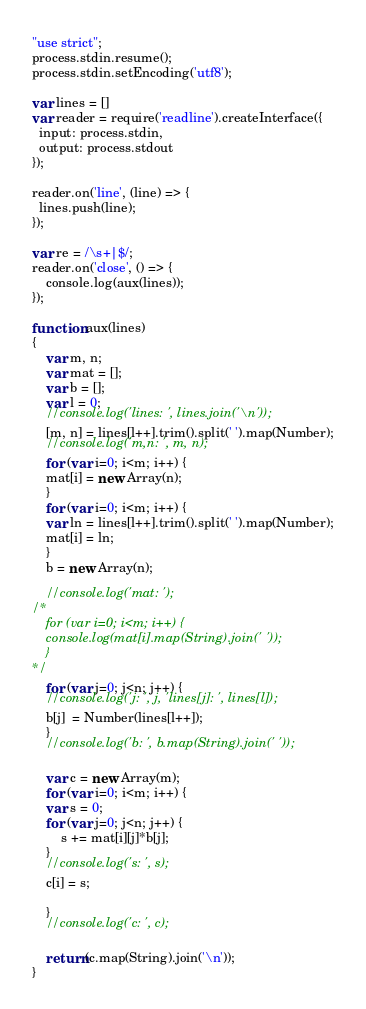Convert code to text. <code><loc_0><loc_0><loc_500><loc_500><_JavaScript_>"use strict";
process.stdin.resume();
process.stdin.setEncoding('utf8');

var lines = []
var reader = require('readline').createInterface({
  input: process.stdin,
  output: process.stdout
});

reader.on('line', (line) => {
  lines.push(line);
});

var re = /\s+|$/;
reader.on('close', () => {
    console.log(aux(lines));
});

function aux(lines)
{
    var m, n;
    var mat = [];
    var b = [];
    var l = 0;
    //console.log('lines: ', lines.join('\n'));
    [m, n] = lines[l++].trim().split(' ').map(Number);
    //console.log('m,n: ', m, n);
    for (var i=0; i<m; i++) {
	mat[i] = new Array(n);
    }
    for (var i=0; i<m; i++) {
	var ln = lines[l++].trim().split(' ').map(Number);
	mat[i] = ln;
    }
    b = new Array(n);

    //console.log('mat: ');
/*
    for (var i=0; i<m; i++) {
	console.log(mat[i].map(String).join(' '));
    }
*/
    for (var j=0; j<n; j++) {
	//console.log('j: ', j, 'lines[j]: ', lines[l]);
	b[j]  = Number(lines[l++]);
    }
    //console.log('b: ', b.map(String).join(' '));

    var c = new Array(m);
    for (var i=0; i<m; i++) {
	var s = 0;
	for (var j=0; j<n; j++) {
	    s += mat[i][j]*b[j];
	}
	//console.log('s: ', s);
	c[i] = s;
	
    }
    //console.log('c: ', c);

    return(c.map(String).join('\n'));
}
</code> 